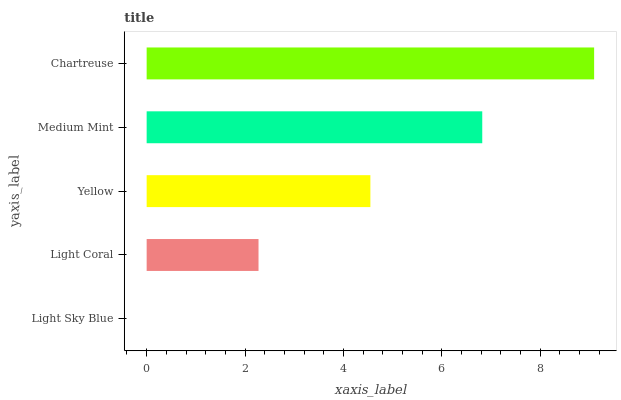Is Light Sky Blue the minimum?
Answer yes or no. Yes. Is Chartreuse the maximum?
Answer yes or no. Yes. Is Light Coral the minimum?
Answer yes or no. No. Is Light Coral the maximum?
Answer yes or no. No. Is Light Coral greater than Light Sky Blue?
Answer yes or no. Yes. Is Light Sky Blue less than Light Coral?
Answer yes or no. Yes. Is Light Sky Blue greater than Light Coral?
Answer yes or no. No. Is Light Coral less than Light Sky Blue?
Answer yes or no. No. Is Yellow the high median?
Answer yes or no. Yes. Is Yellow the low median?
Answer yes or no. Yes. Is Chartreuse the high median?
Answer yes or no. No. Is Light Sky Blue the low median?
Answer yes or no. No. 